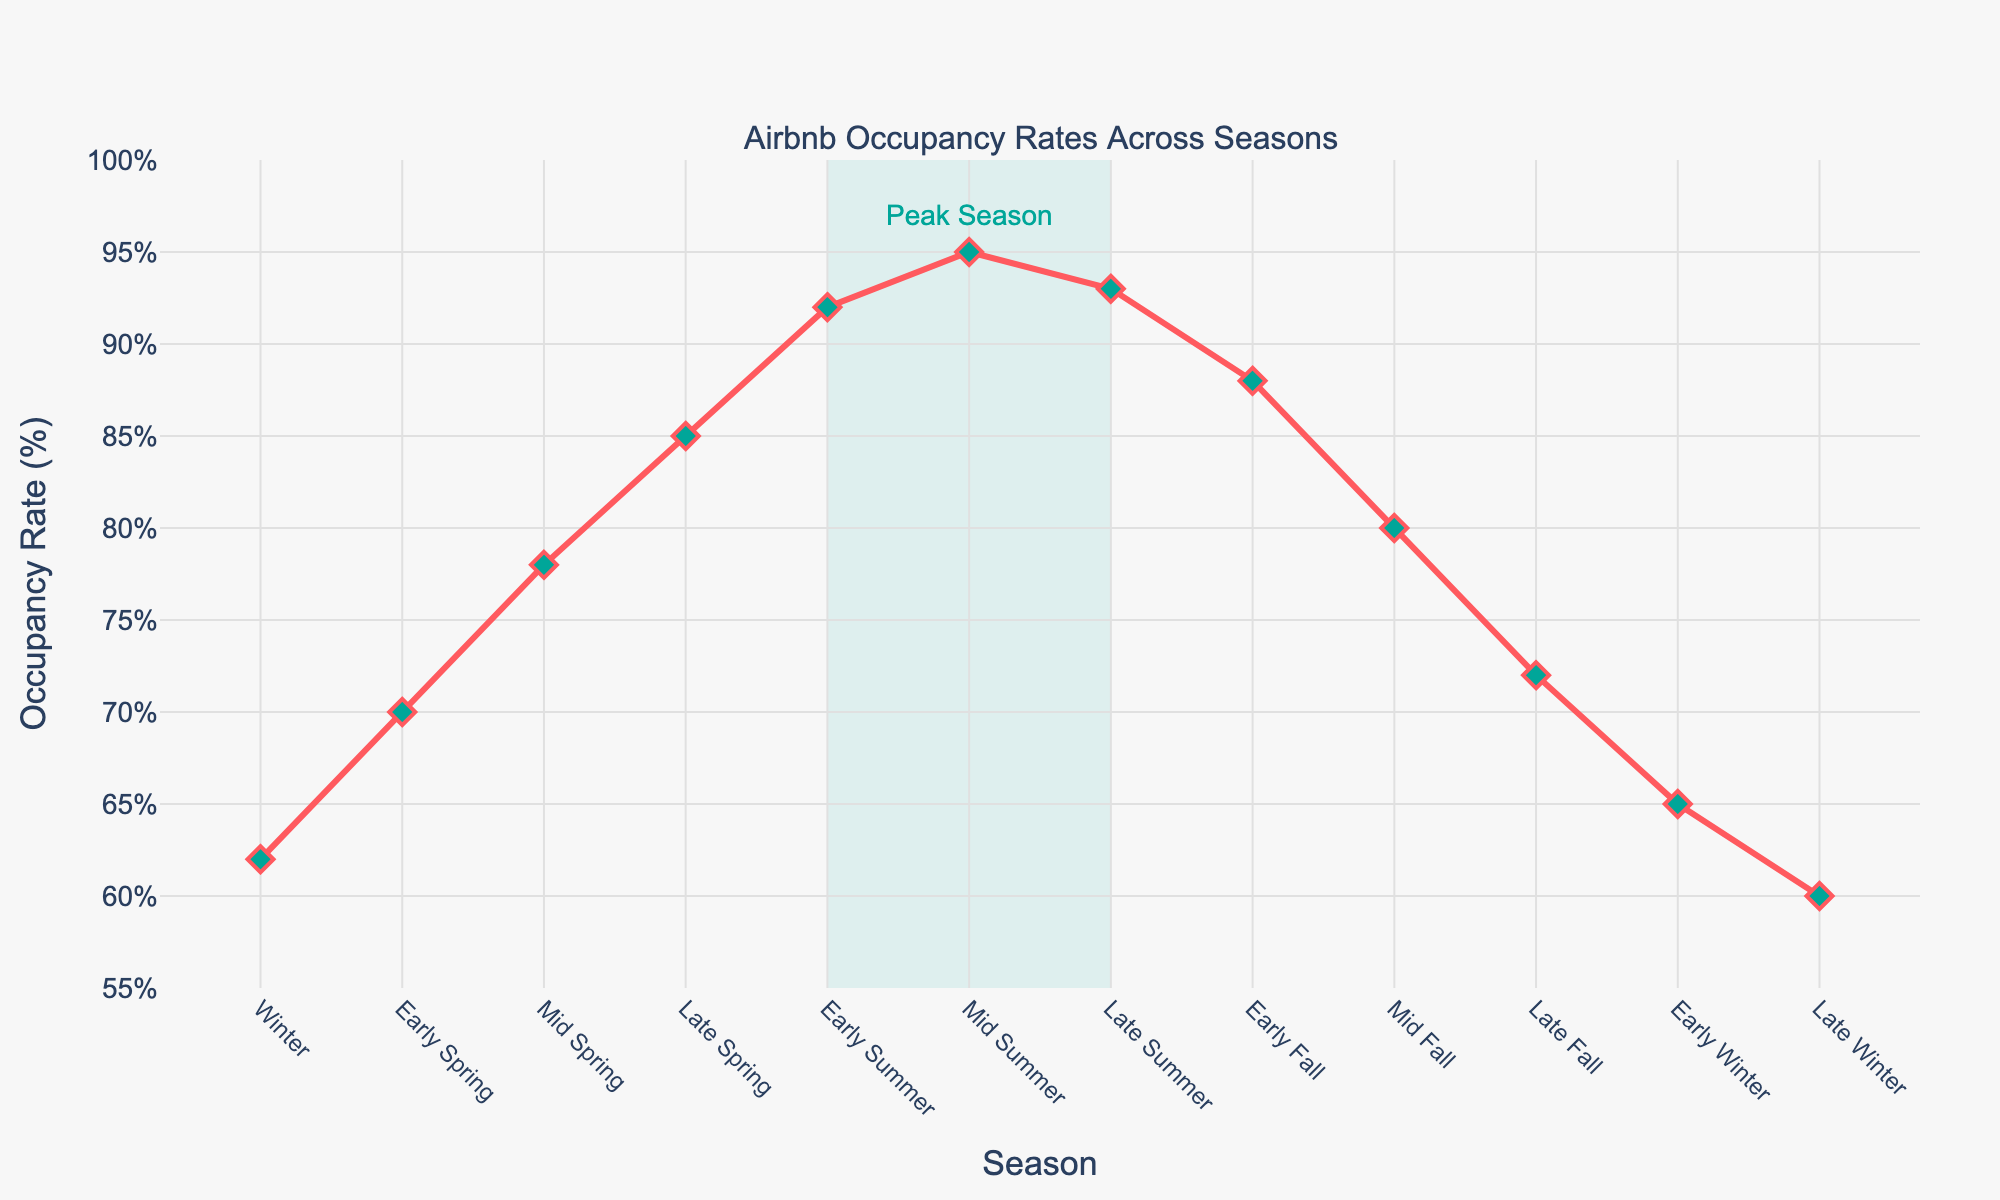What is the highest occupancy rate, and in which season does it occur? The highest point on the line graph is at "Mid Summer" with an occupancy rate of 95%.
Answer: 95%, Mid Summer What is the difference in occupancy rate between Early Spring and Early Fall? Looking at the points for Early Spring (70%) and Early Fall (88%), the difference is calculated as 88% - 70% = 18%.
Answer: 18% During which seasons does the occupancy rate exceed 90%? The line graph shows that the occupancy rate exceeds 90% in Early Summer (92%), Mid Summer (95%), and Late Summer (93%).
Answer: Early Summer, Mid Summer, Late Summer In which season is the occupancy rate the lowest, and what is the rate? The lowest point on the line graph is at "Late Winter" with an occupancy rate of 60%.
Answer: Late Winter, 60% How does the occupancy rate change from Early Winter to Late Winter? From the line graph, Early Winter has an occupancy rate of 65%, decreasing to 60% in Late Winter. The change is 65% - 60% = 5% decrease.
Answer: 5% decrease What’s the average occupancy rate for all the seasons shown? Sum all occupancy rates: 62 + 70 + 78 + 85 + 92 + 95 + 93 + 88 + 80 + 72 + 65 + 60 = 940. There are 12 data points, so average = 940/12 ≈ 78.33%.
Answer: 78.33% Compare the occupancy rates of Mid Spring and Mid Fall. Which is higher and by how much? The occupancy rate in Mid Spring is 78%, and in Mid Fall, it is 80%. The difference is 80% - 78% = 2%, so, Mid Fall is higher by 2%.
Answer: Mid Fall, 2% What visual indication is used to highlight the peak season on the plot? The plot uses a light green rectangular highlight around the peak season (Early Summer to Late Summer) with an annotation "Peak Season".
Answer: Light green rectangle, "Peak Season" Which seasons show a consistent increase in occupancy rate, and what is the range of this increase? From the line graph, the occupancy rate consistently increases from Winter (62%) to Late Spring (85%). The range of increase is 85% - 62% = 23%.
Answer: Winter to Late Spring, 23% Is there a season where the occupancy rate drops compared to the previous season, and if so, which one? Yes, the occupancy rate drops from Late Summer (93%) to Early Fall (88%), from Mid Fall (80%) to Late Fall (72%), and from Early Winter (65%) to Late Winter (60%).
Answer: Late Summer to Early Fall; Mid Fall to Late Fall; Early Winter to Late Winter 